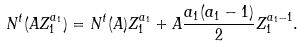<formula> <loc_0><loc_0><loc_500><loc_500>N ^ { t } ( A Z _ { 1 } ^ { a _ { 1 } } ) = N ^ { t } ( A ) Z _ { 1 } ^ { a _ { 1 } } + A \frac { a _ { 1 } ( a _ { 1 } - 1 ) } { 2 } Z _ { 1 } ^ { a _ { 1 } - 1 } .</formula> 